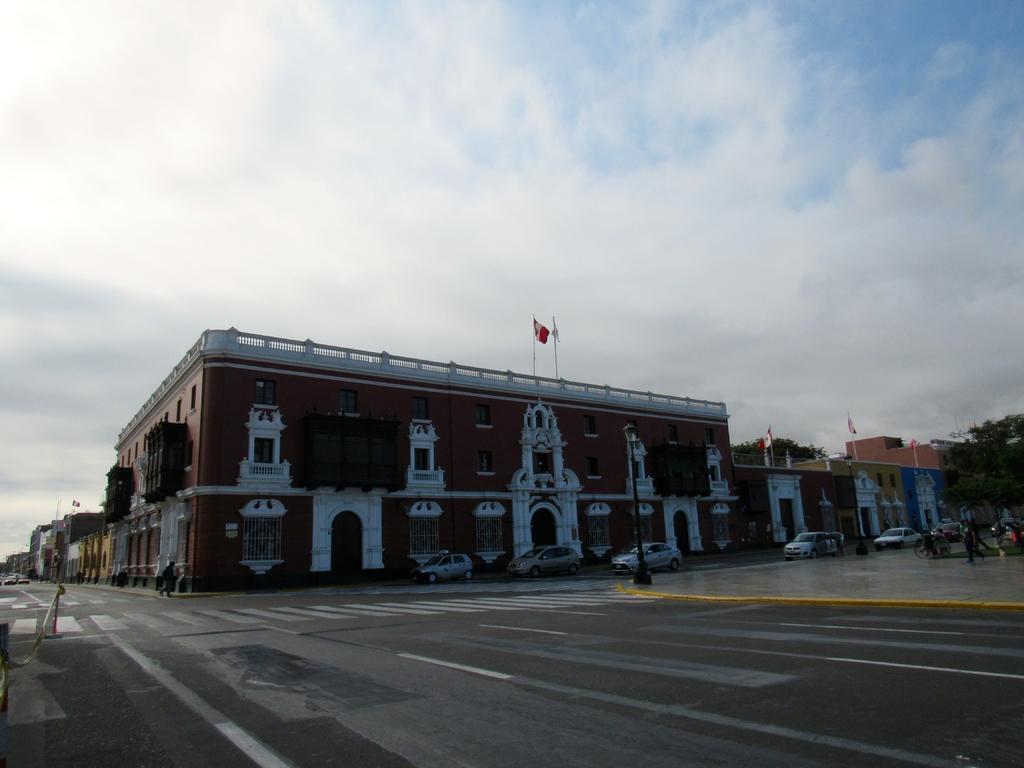Describe this image in one or two sentences. In this picture there are buildings and trees and there are street lights and there are vehicles on the road. On the left side of the image there is a person walking on the road. On the right side of the image there is a person walking on the road and there are flags on the top of the buildings. At the top there is sky and there are clouds. At the bottom there is a road. 